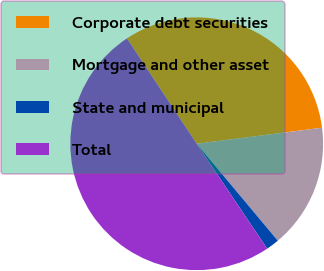Convert chart to OTSL. <chart><loc_0><loc_0><loc_500><loc_500><pie_chart><fcel>Corporate debt securities<fcel>Mortgage and other asset<fcel>State and municipal<fcel>Total<nl><fcel>32.28%<fcel>15.94%<fcel>1.67%<fcel>50.1%<nl></chart> 